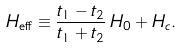Convert formula to latex. <formula><loc_0><loc_0><loc_500><loc_500>H _ { \text {eff} } \equiv \frac { t _ { 1 } - t _ { 2 } } { t _ { 1 } + t _ { 2 } } \, H _ { 0 } + H _ { c } .</formula> 